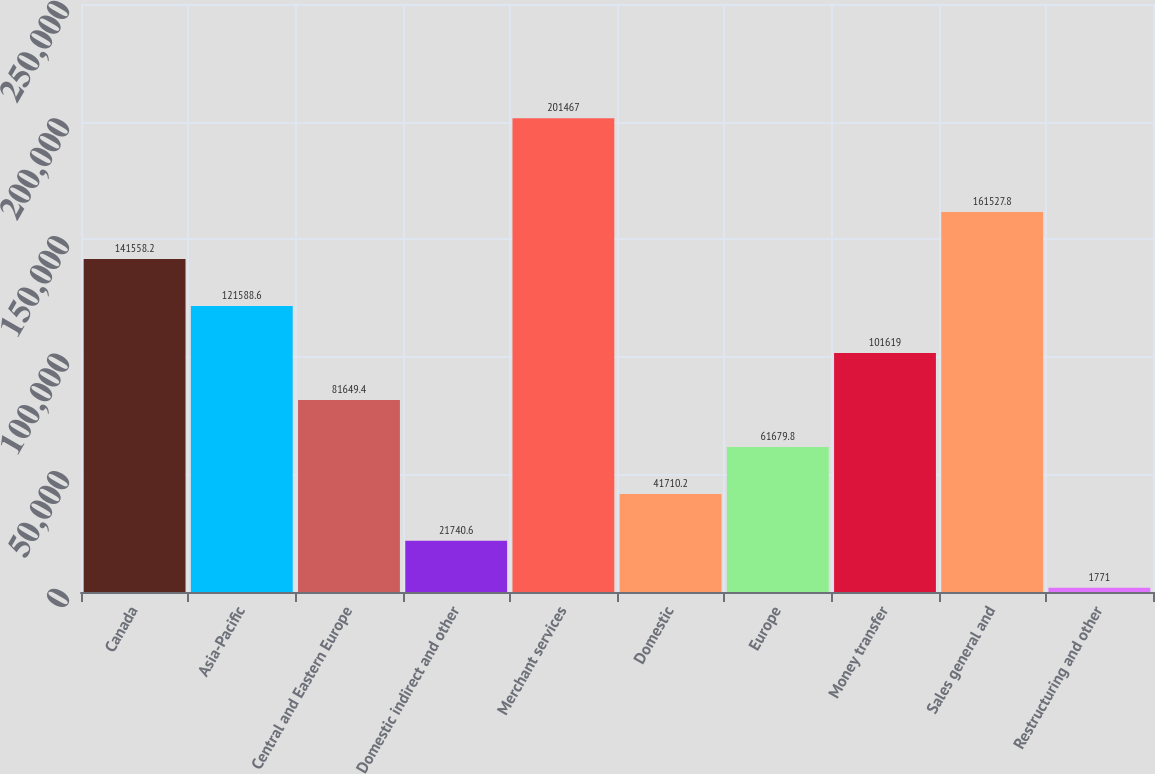Convert chart. <chart><loc_0><loc_0><loc_500><loc_500><bar_chart><fcel>Canada<fcel>Asia-Pacific<fcel>Central and Eastern Europe<fcel>Domestic indirect and other<fcel>Merchant services<fcel>Domestic<fcel>Europe<fcel>Money transfer<fcel>Sales general and<fcel>Restructuring and other<nl><fcel>141558<fcel>121589<fcel>81649.4<fcel>21740.6<fcel>201467<fcel>41710.2<fcel>61679.8<fcel>101619<fcel>161528<fcel>1771<nl></chart> 